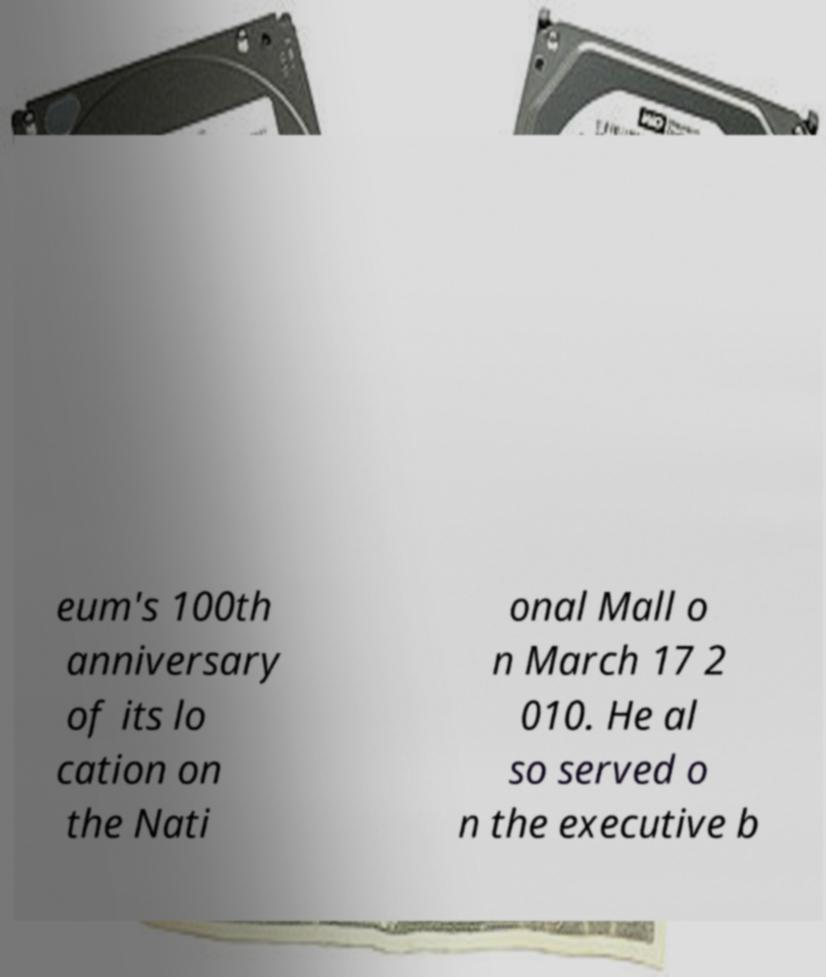Could you assist in decoding the text presented in this image and type it out clearly? eum's 100th anniversary of its lo cation on the Nati onal Mall o n March 17 2 010. He al so served o n the executive b 